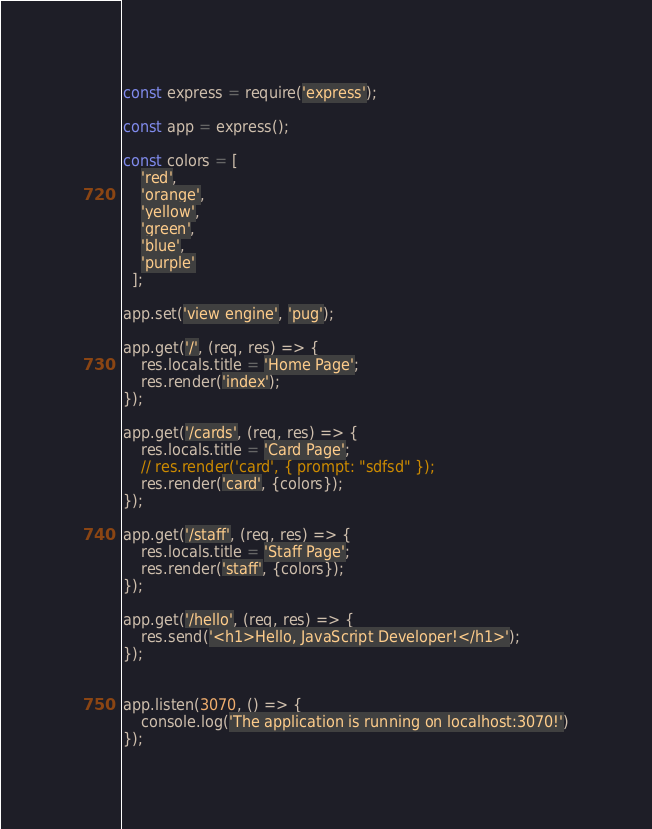Convert code to text. <code><loc_0><loc_0><loc_500><loc_500><_JavaScript_>const express = require('express');

const app = express();

const colors = [
    'red',
    'orange',
    'yellow',
    'green',
    'blue',
    'purple'
  ];

app.set('view engine', 'pug');

app.get('/', (req, res) => {
    res.locals.title = 'Home Page';
    res.render('index');
});

app.get('/cards', (req, res) => {
    res.locals.title = 'Card Page';
    // res.render('card', { prompt: "sdfsd" });
    res.render('card', {colors});
});

app.get('/staff', (req, res) => {
    res.locals.title = 'Staff Page';
    res.render('staff', {colors});
});

app.get('/hello', (req, res) => {
    res.send('<h1>Hello, JavaScript Developer!</h1>');
});


app.listen(3070, () => {
    console.log('The application is running on localhost:3070!')
});</code> 